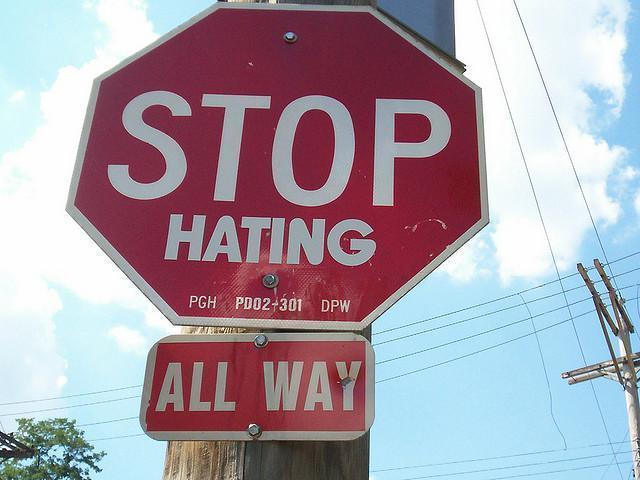How many buses are here?
Give a very brief answer. 0. 